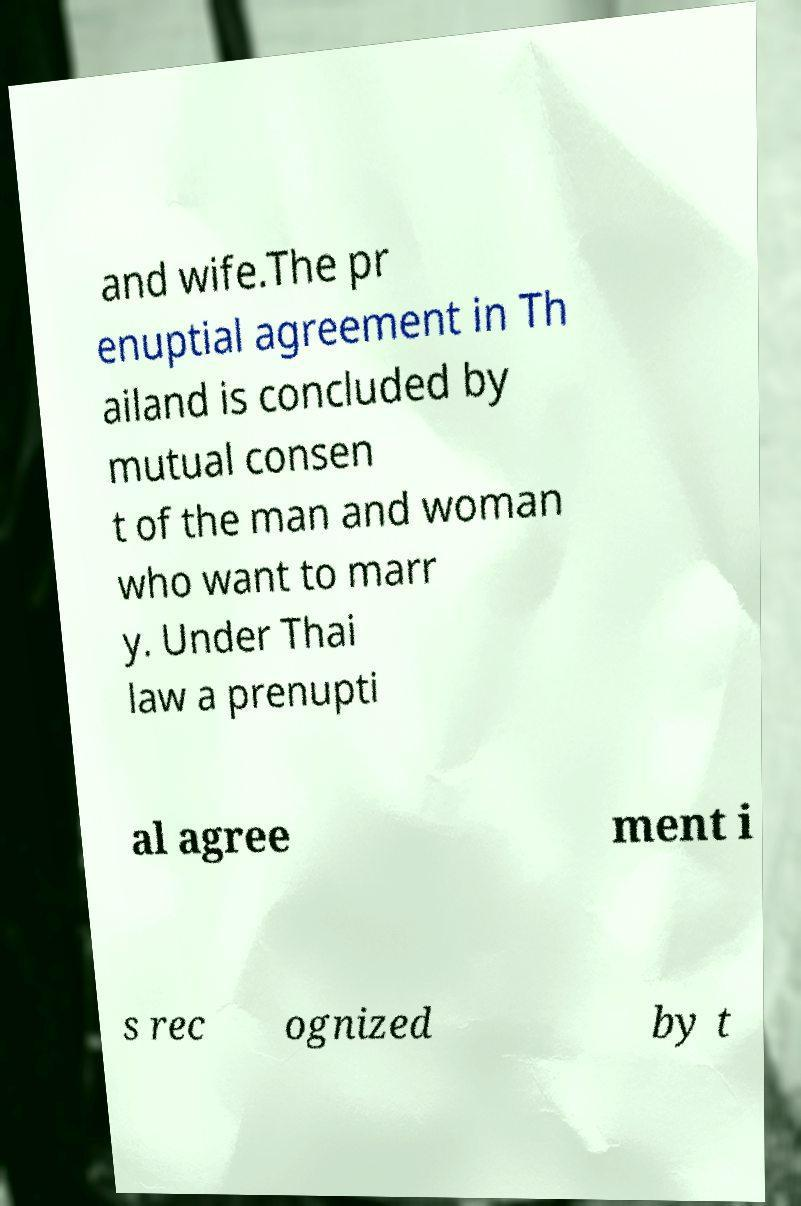Could you assist in decoding the text presented in this image and type it out clearly? and wife.The pr enuptial agreement in Th ailand is concluded by mutual consen t of the man and woman who want to marr y. Under Thai law a prenupti al agree ment i s rec ognized by t 